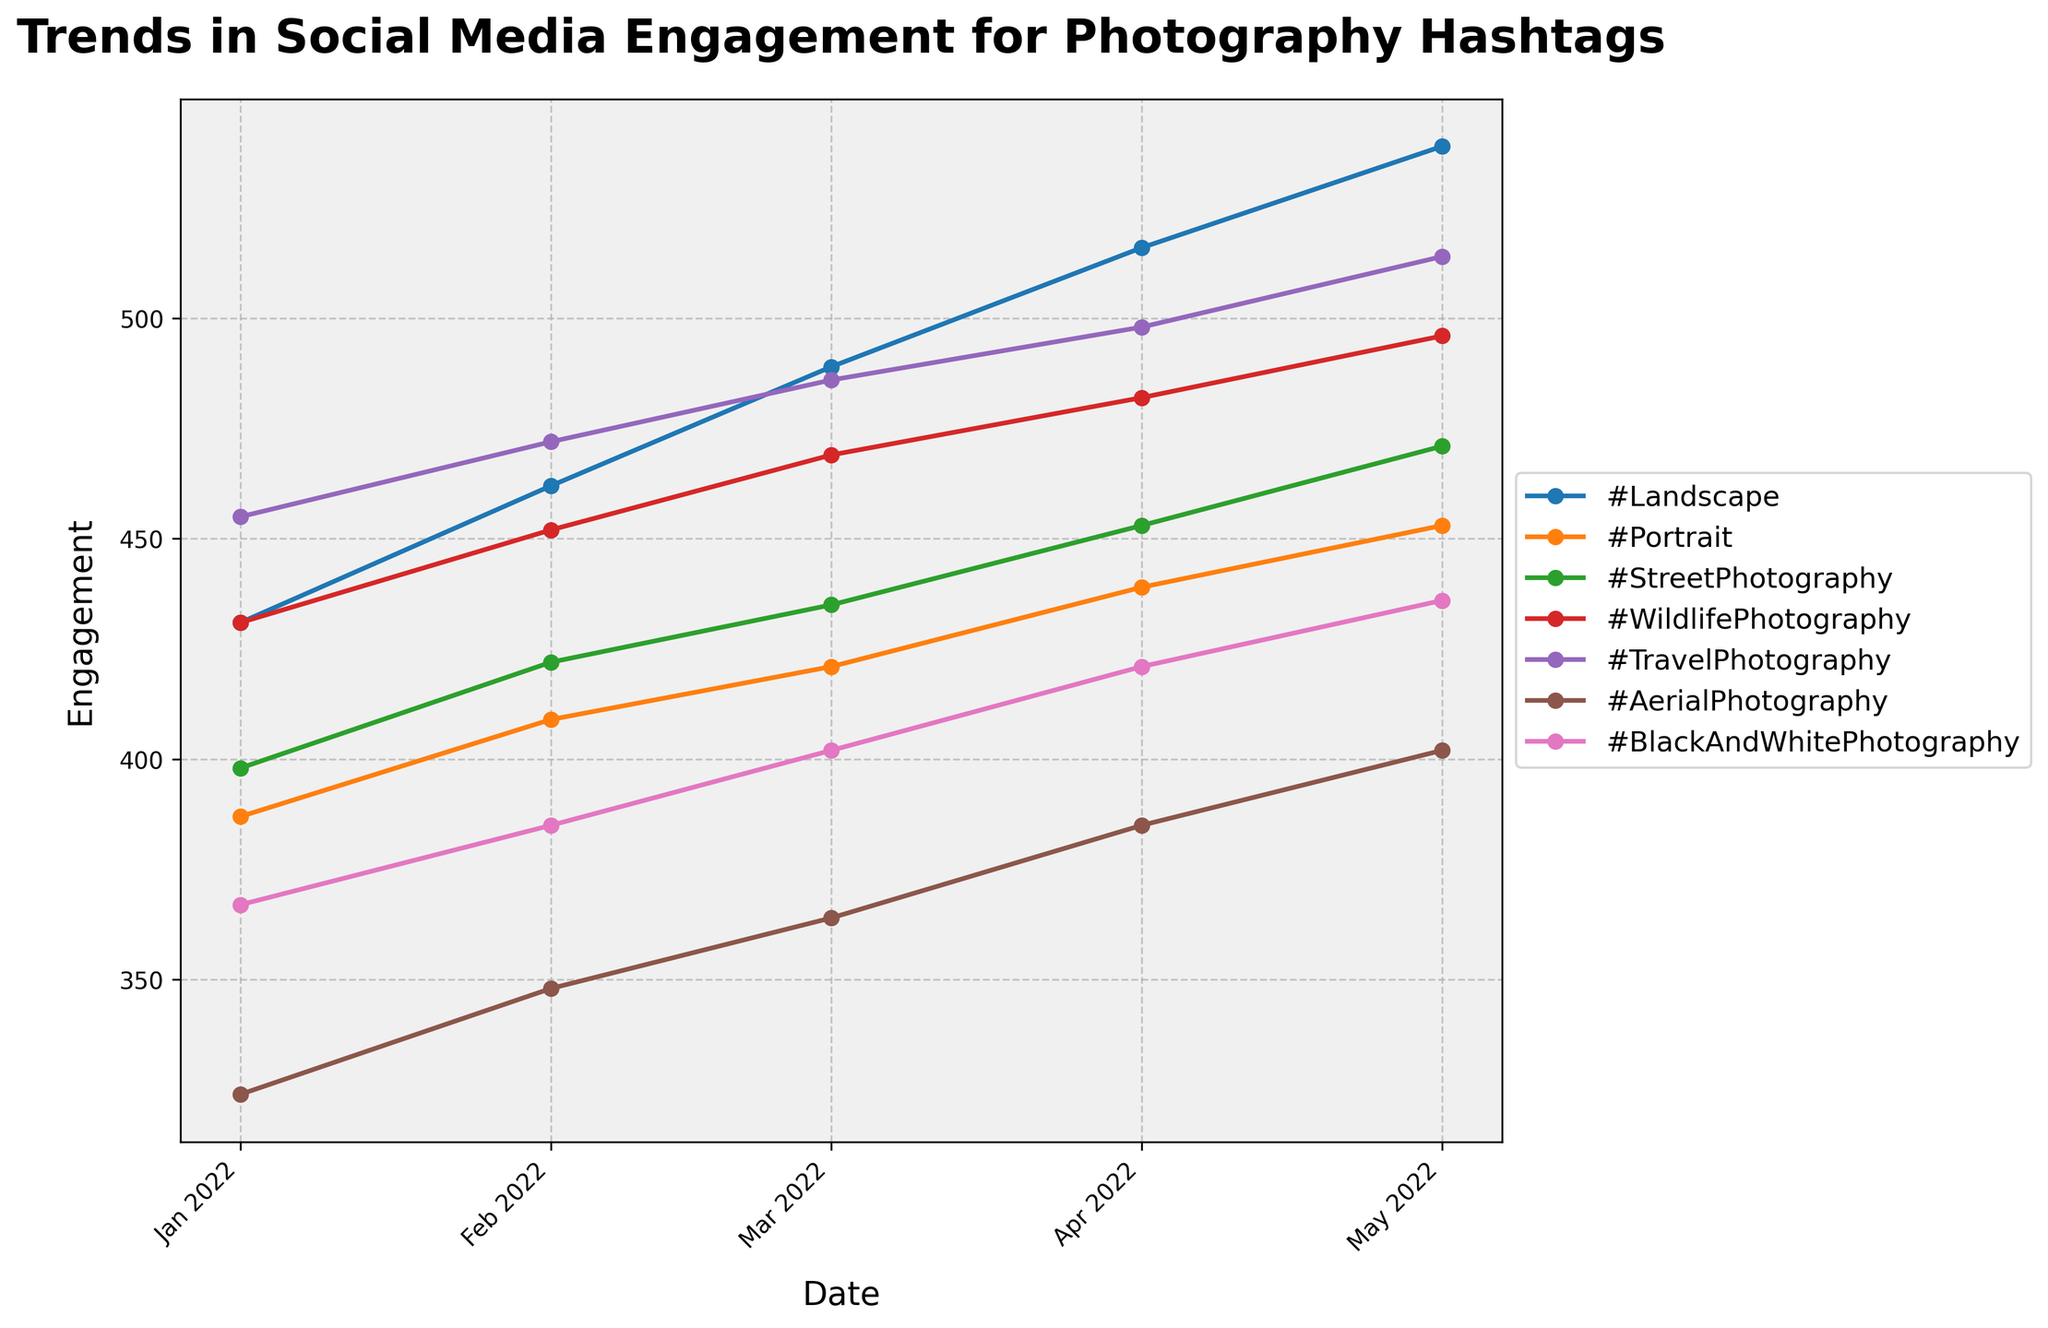What is the title of the plot? The title is located at the top of the plot, typically in larger and bold font for prominence. The title summarizes what the plot is about.
Answer: Trends in Social Media Engagement for Photography Hashtags Which hashtag shows the highest engagement in April 2022? Look at the data points for April 2022 on the x-axis and find the highest y-value among the different hashtags.
Answer: #TravelPhotography How does the engagement for #WildlifePhotography change from January 2022 to May 2022? Trace the line corresponding to #WildlifePhotography from January to May 2022 on the x-axis to observe the changes in the y-values.
Answer: It increases Which two hashtags have their lines crossing multiple times over the time period? Follow the lines for any pairs of hashtags and note any intersections from January to May 2022.
Answer: #Portrait and #StreetPhotography What is the engagement trend for #AerialPhotography? Observe the line representing #AerialPhotography and note whether it generally increases, decreases, or remains stable over time.
Answer: Increasing Compare the engagement for #BlackAndWhitePhotography and #WildlifePhotography in March 2022. Which is higher? Identify both data points for March 2022 and compare their y-values.
Answer: #WildlifePhotography Which months show the highest engagement for #Portrait? Look at the y-values along the timeline for the #Portrait line and identify the months with the highest peaks.
Answer: May 2022 What can be said about the engagement for #TravelPhotography compared to other hashtags? Compare the y-values and line trend of #TravelPhotography with other hashtags over the entire time period.
Answer: Consistently high What is the general trend in engagement for #Landscape from January to May 2022? Observe the line for #Landscape across the timeline and note whether it generally moves upward, downward, or remains stable.
Answer: Increasing Are there any hashtags that consistently show lower engagement across the months? Identify any hashtags with consistently lower y-values throughout the timeline.
Answer: #AerialPhotography 